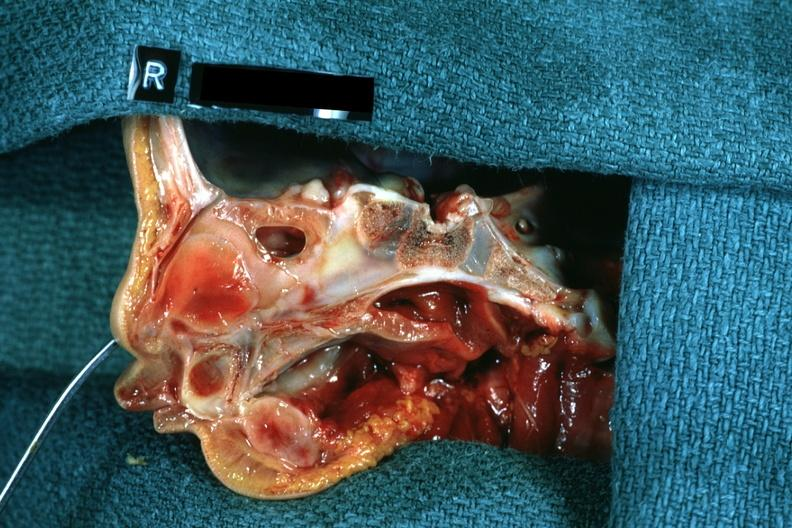does pus in test tube show right side atresia left was patent hemisection of nose?
Answer the question using a single word or phrase. No 